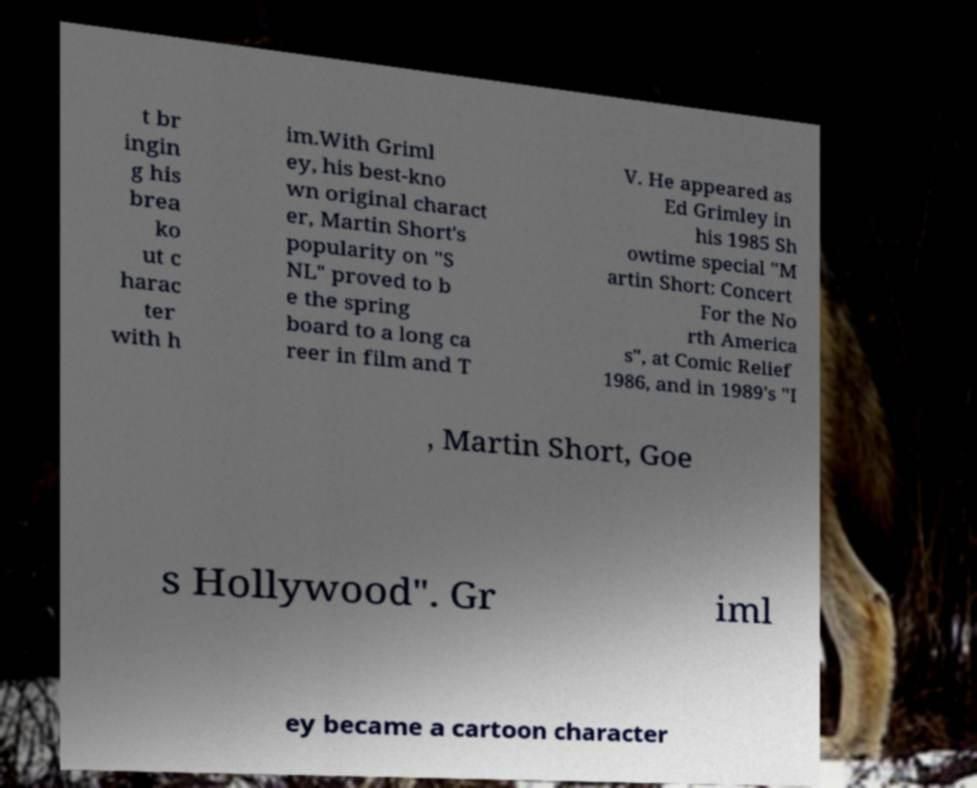For documentation purposes, I need the text within this image transcribed. Could you provide that? t br ingin g his brea ko ut c harac ter with h im.With Griml ey, his best-kno wn original charact er, Martin Short's popularity on "S NL" proved to b e the spring board to a long ca reer in film and T V. He appeared as Ed Grimley in his 1985 Sh owtime special "M artin Short: Concert For the No rth America s", at Comic Relief 1986, and in 1989's "I , Martin Short, Goe s Hollywood". Gr iml ey became a cartoon character 